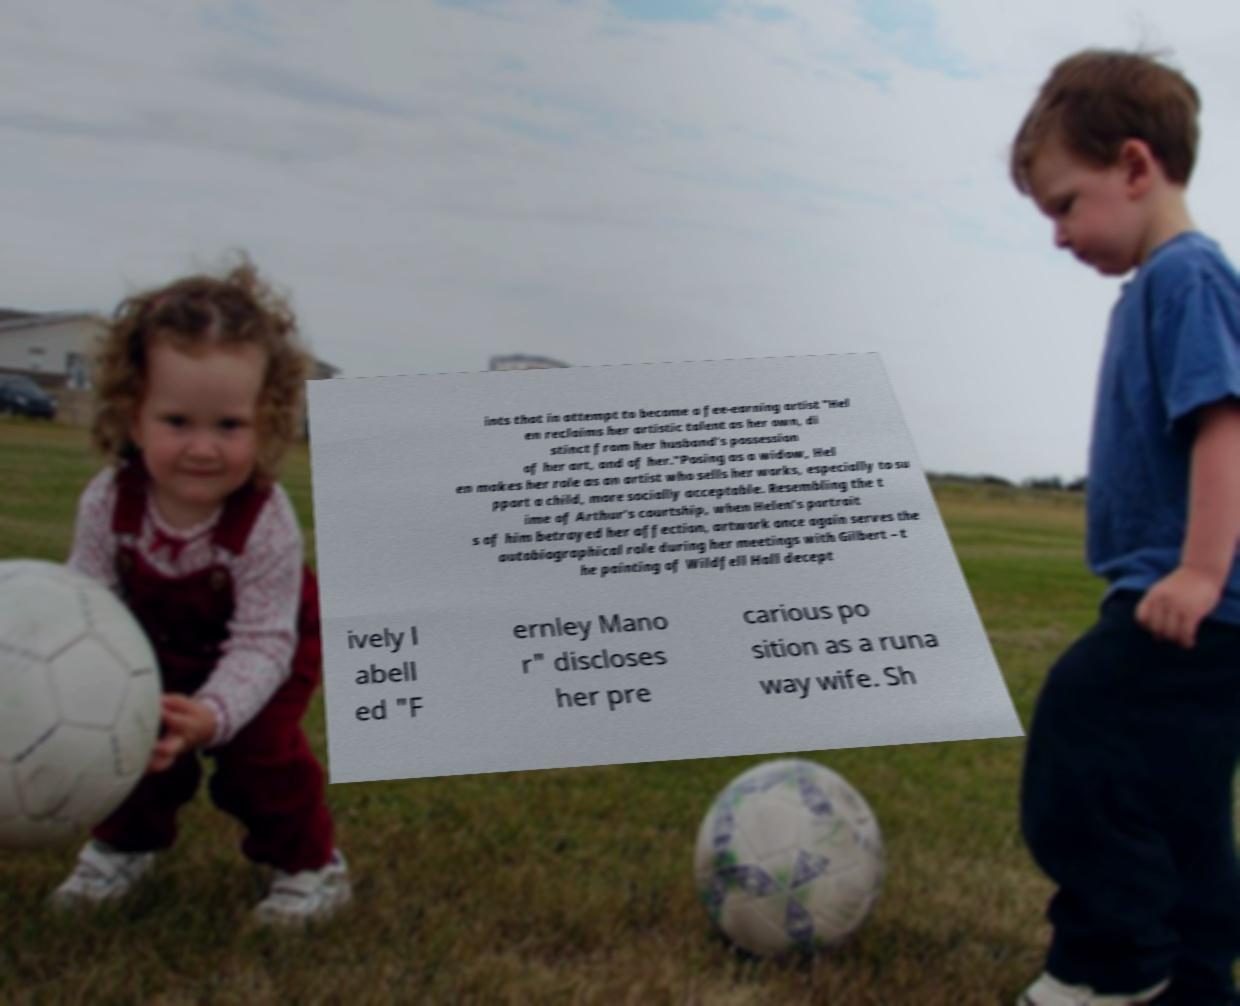For documentation purposes, I need the text within this image transcribed. Could you provide that? ints that in attempt to become a fee-earning artist "Hel en reclaims her artistic talent as her own, di stinct from her husband's possession of her art, and of her."Posing as a widow, Hel en makes her role as an artist who sells her works, especially to su pport a child, more socially acceptable. Resembling the t ime of Arthur's courtship, when Helen's portrait s of him betrayed her affection, artwork once again serves the autobiographical role during her meetings with Gilbert – t he painting of Wildfell Hall decept ively l abell ed "F ernley Mano r" discloses her pre carious po sition as a runa way wife. Sh 